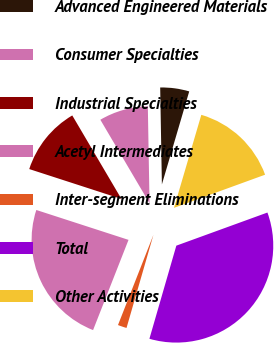<chart> <loc_0><loc_0><loc_500><loc_500><pie_chart><fcel>Advanced Engineered Materials<fcel>Consumer Specialties<fcel>Industrial Specialties<fcel>Acetyl Intermediates<fcel>Inter-segment Eliminations<fcel>Total<fcel>Other Activities<nl><fcel>4.83%<fcel>8.19%<fcel>11.54%<fcel>24.03%<fcel>1.48%<fcel>35.03%<fcel>14.9%<nl></chart> 